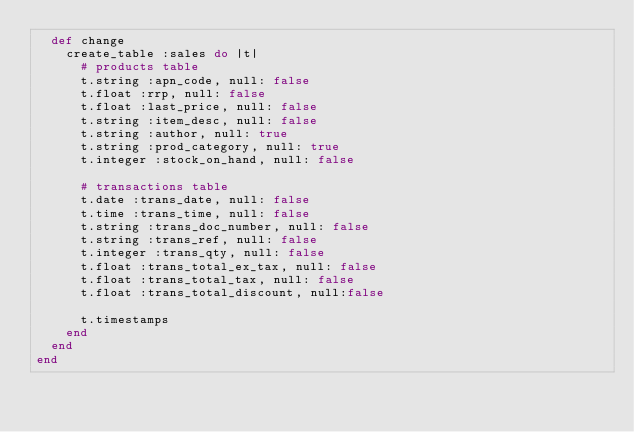<code> <loc_0><loc_0><loc_500><loc_500><_Ruby_>  def change
    create_table :sales do |t|
      # products table
      t.string :apn_code, null: false
      t.float :rrp, null: false
      t.float :last_price, null: false
      t.string :item_desc, null: false
      t.string :author, null: true
      t.string :prod_category, null: true
      t.integer :stock_on_hand, null: false

      # transactions table
      t.date :trans_date, null: false
      t.time :trans_time, null: false
      t.string :trans_doc_number, null: false
      t.string :trans_ref, null: false
      t.integer :trans_qty, null: false
      t.float :trans_total_ex_tax, null: false
      t.float :trans_total_tax, null: false
      t.float :trans_total_discount, null:false

      t.timestamps
    end
  end
end
</code> 